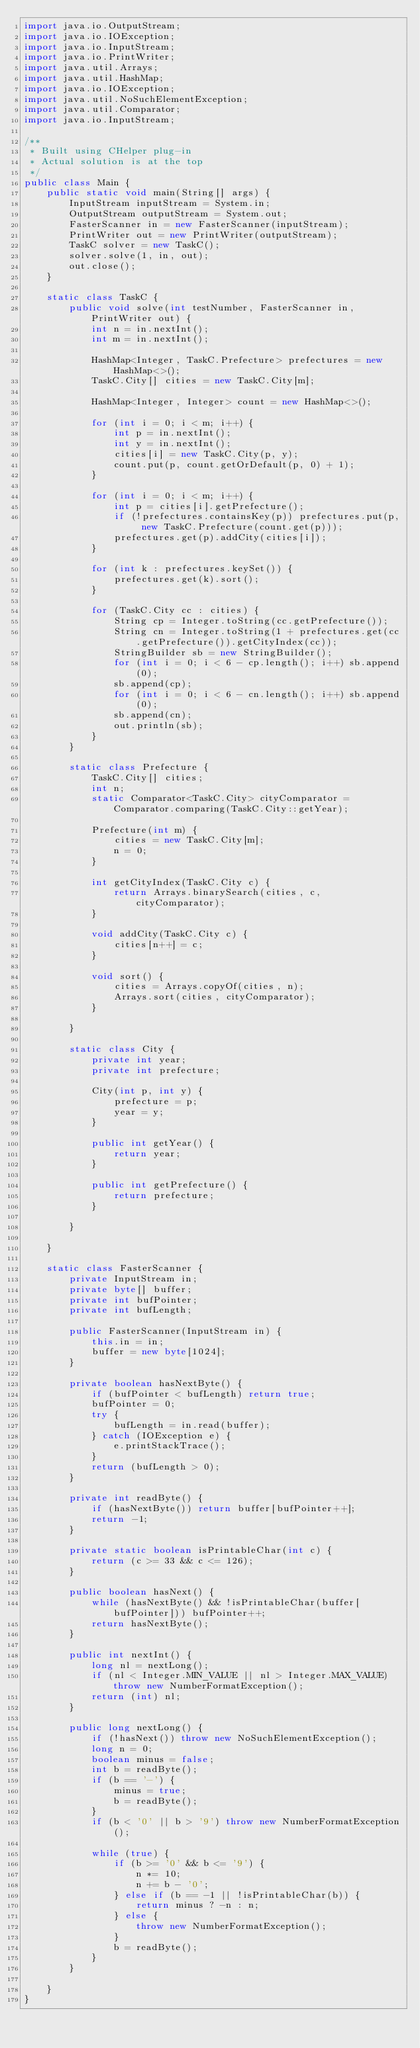Convert code to text. <code><loc_0><loc_0><loc_500><loc_500><_Java_>import java.io.OutputStream;
import java.io.IOException;
import java.io.InputStream;
import java.io.PrintWriter;
import java.util.Arrays;
import java.util.HashMap;
import java.io.IOException;
import java.util.NoSuchElementException;
import java.util.Comparator;
import java.io.InputStream;

/**
 * Built using CHelper plug-in
 * Actual solution is at the top
 */
public class Main {
    public static void main(String[] args) {
        InputStream inputStream = System.in;
        OutputStream outputStream = System.out;
        FasterScanner in = new FasterScanner(inputStream);
        PrintWriter out = new PrintWriter(outputStream);
        TaskC solver = new TaskC();
        solver.solve(1, in, out);
        out.close();
    }

    static class TaskC {
        public void solve(int testNumber, FasterScanner in, PrintWriter out) {
            int n = in.nextInt();
            int m = in.nextInt();

            HashMap<Integer, TaskC.Prefecture> prefectures = new HashMap<>();
            TaskC.City[] cities = new TaskC.City[m];

            HashMap<Integer, Integer> count = new HashMap<>();

            for (int i = 0; i < m; i++) {
                int p = in.nextInt();
                int y = in.nextInt();
                cities[i] = new TaskC.City(p, y);
                count.put(p, count.getOrDefault(p, 0) + 1);
            }

            for (int i = 0; i < m; i++) {
                int p = cities[i].getPrefecture();
                if (!prefectures.containsKey(p)) prefectures.put(p, new TaskC.Prefecture(count.get(p)));
                prefectures.get(p).addCity(cities[i]);
            }

            for (int k : prefectures.keySet()) {
                prefectures.get(k).sort();
            }

            for (TaskC.City cc : cities) {
                String cp = Integer.toString(cc.getPrefecture());
                String cn = Integer.toString(1 + prefectures.get(cc.getPrefecture()).getCityIndex(cc));
                StringBuilder sb = new StringBuilder();
                for (int i = 0; i < 6 - cp.length(); i++) sb.append(0);
                sb.append(cp);
                for (int i = 0; i < 6 - cn.length(); i++) sb.append(0);
                sb.append(cn);
                out.println(sb);
            }
        }

        static class Prefecture {
            TaskC.City[] cities;
            int n;
            static Comparator<TaskC.City> cityComparator = Comparator.comparing(TaskC.City::getYear);

            Prefecture(int m) {
                cities = new TaskC.City[m];
                n = 0;
            }

            int getCityIndex(TaskC.City c) {
                return Arrays.binarySearch(cities, c, cityComparator);
            }

            void addCity(TaskC.City c) {
                cities[n++] = c;
            }

            void sort() {
                cities = Arrays.copyOf(cities, n);
                Arrays.sort(cities, cityComparator);
            }

        }

        static class City {
            private int year;
            private int prefecture;

            City(int p, int y) {
                prefecture = p;
                year = y;
            }

            public int getYear() {
                return year;
            }

            public int getPrefecture() {
                return prefecture;
            }

        }

    }

    static class FasterScanner {
        private InputStream in;
        private byte[] buffer;
        private int bufPointer;
        private int bufLength;

        public FasterScanner(InputStream in) {
            this.in = in;
            buffer = new byte[1024];
        }

        private boolean hasNextByte() {
            if (bufPointer < bufLength) return true;
            bufPointer = 0;
            try {
                bufLength = in.read(buffer);
            } catch (IOException e) {
                e.printStackTrace();
            }
            return (bufLength > 0);
        }

        private int readByte() {
            if (hasNextByte()) return buffer[bufPointer++];
            return -1;
        }

        private static boolean isPrintableChar(int c) {
            return (c >= 33 && c <= 126);
        }

        public boolean hasNext() {
            while (hasNextByte() && !isPrintableChar(buffer[bufPointer])) bufPointer++;
            return hasNextByte();
        }

        public int nextInt() {
            long nl = nextLong();
            if (nl < Integer.MIN_VALUE || nl > Integer.MAX_VALUE) throw new NumberFormatException();
            return (int) nl;
        }

        public long nextLong() {
            if (!hasNext()) throw new NoSuchElementException();
            long n = 0;
            boolean minus = false;
            int b = readByte();
            if (b == '-') {
                minus = true;
                b = readByte();
            }
            if (b < '0' || b > '9') throw new NumberFormatException();

            while (true) {
                if (b >= '0' && b <= '9') {
                    n *= 10;
                    n += b - '0';
                } else if (b == -1 || !isPrintableChar(b)) {
                    return minus ? -n : n;
                } else {
                    throw new NumberFormatException();
                }
                b = readByte();
            }
        }

    }
}

</code> 